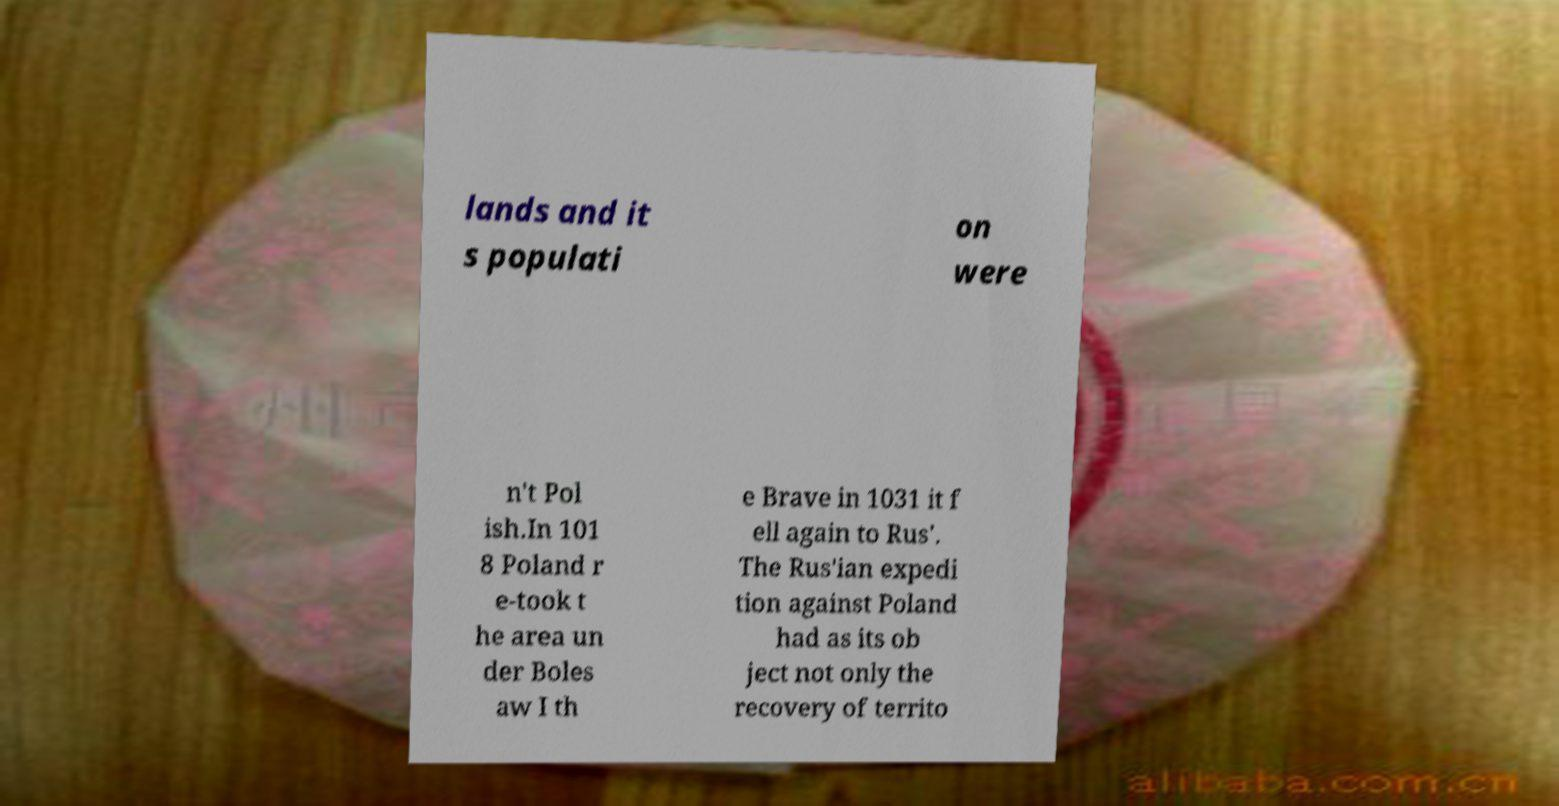Can you accurately transcribe the text from the provided image for me? lands and it s populati on were n't Pol ish.In 101 8 Poland r e-took t he area un der Boles aw I th e Brave in 1031 it f ell again to Rus'. The Rus'ian expedi tion against Poland had as its ob ject not only the recovery of territo 